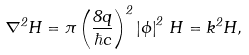Convert formula to latex. <formula><loc_0><loc_0><loc_500><loc_500>\nabla ^ { 2 } { H } = \pi \left ( \frac { 8 q } { \hbar { c } } \right ) ^ { 2 } \left | \phi \right | ^ { 2 } \, { H } = k ^ { 2 } { H , }</formula> 